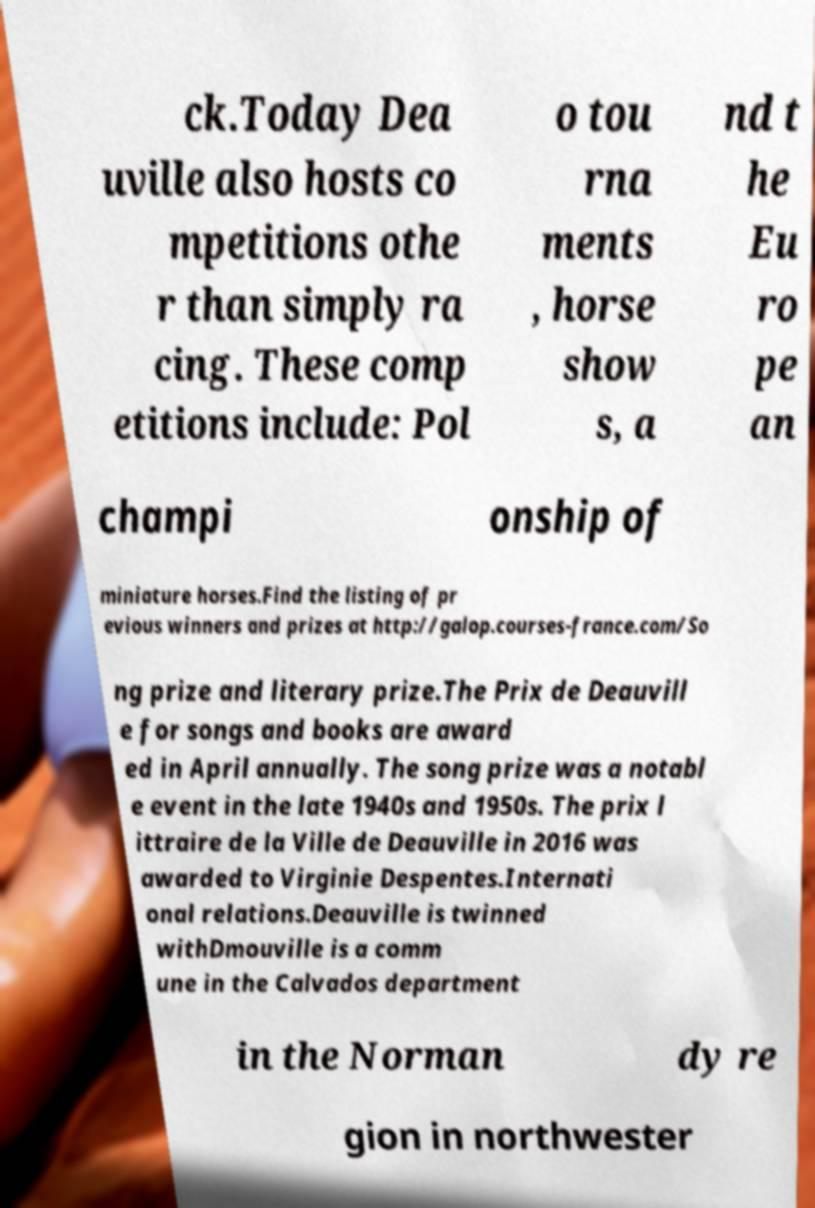Could you assist in decoding the text presented in this image and type it out clearly? ck.Today Dea uville also hosts co mpetitions othe r than simply ra cing. These comp etitions include: Pol o tou rna ments , horse show s, a nd t he Eu ro pe an champi onship of miniature horses.Find the listing of pr evious winners and prizes at http://galop.courses-france.com/So ng prize and literary prize.The Prix de Deauvill e for songs and books are award ed in April annually. The song prize was a notabl e event in the late 1940s and 1950s. The prix l ittraire de la Ville de Deauville in 2016 was awarded to Virginie Despentes.Internati onal relations.Deauville is twinned withDmouville is a comm une in the Calvados department in the Norman dy re gion in northwester 